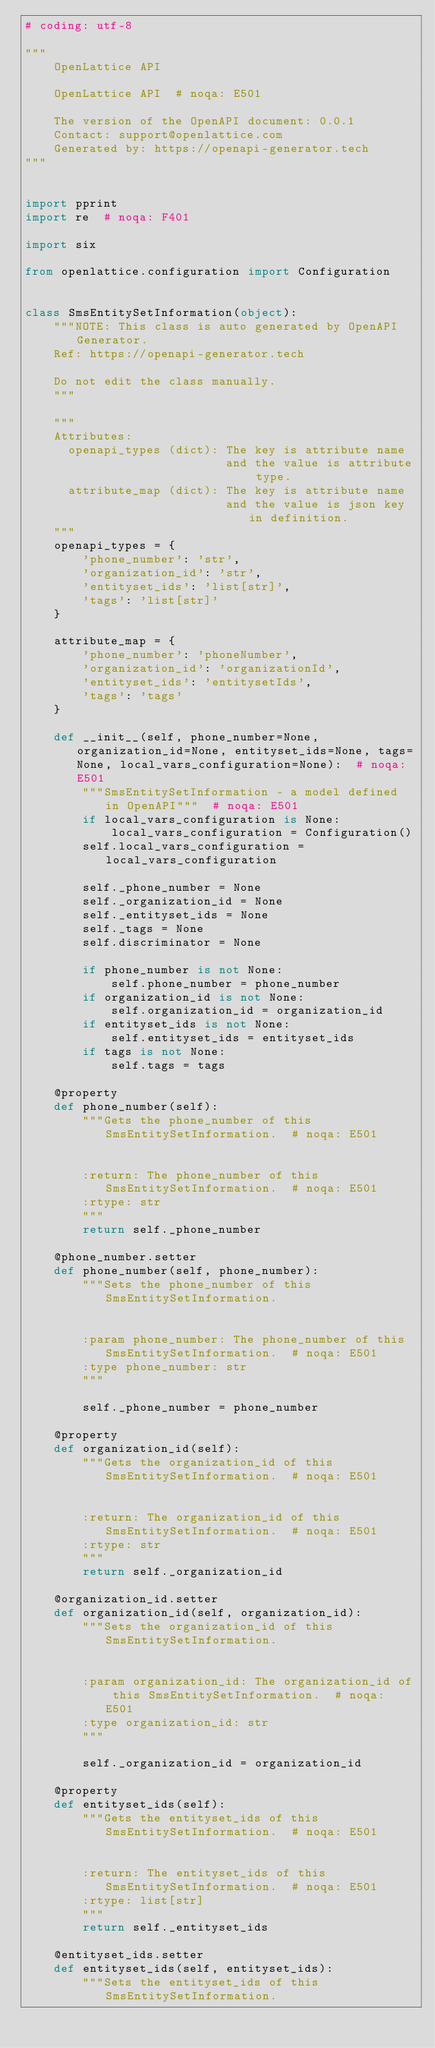Convert code to text. <code><loc_0><loc_0><loc_500><loc_500><_Python_># coding: utf-8

"""
    OpenLattice API

    OpenLattice API  # noqa: E501

    The version of the OpenAPI document: 0.0.1
    Contact: support@openlattice.com
    Generated by: https://openapi-generator.tech
"""


import pprint
import re  # noqa: F401

import six

from openlattice.configuration import Configuration


class SmsEntitySetInformation(object):
    """NOTE: This class is auto generated by OpenAPI Generator.
    Ref: https://openapi-generator.tech

    Do not edit the class manually.
    """

    """
    Attributes:
      openapi_types (dict): The key is attribute name
                            and the value is attribute type.
      attribute_map (dict): The key is attribute name
                            and the value is json key in definition.
    """
    openapi_types = {
        'phone_number': 'str',
        'organization_id': 'str',
        'entityset_ids': 'list[str]',
        'tags': 'list[str]'
    }

    attribute_map = {
        'phone_number': 'phoneNumber',
        'organization_id': 'organizationId',
        'entityset_ids': 'entitysetIds',
        'tags': 'tags'
    }

    def __init__(self, phone_number=None, organization_id=None, entityset_ids=None, tags=None, local_vars_configuration=None):  # noqa: E501
        """SmsEntitySetInformation - a model defined in OpenAPI"""  # noqa: E501
        if local_vars_configuration is None:
            local_vars_configuration = Configuration()
        self.local_vars_configuration = local_vars_configuration

        self._phone_number = None
        self._organization_id = None
        self._entityset_ids = None
        self._tags = None
        self.discriminator = None

        if phone_number is not None:
            self.phone_number = phone_number
        if organization_id is not None:
            self.organization_id = organization_id
        if entityset_ids is not None:
            self.entityset_ids = entityset_ids
        if tags is not None:
            self.tags = tags

    @property
    def phone_number(self):
        """Gets the phone_number of this SmsEntitySetInformation.  # noqa: E501


        :return: The phone_number of this SmsEntitySetInformation.  # noqa: E501
        :rtype: str
        """
        return self._phone_number

    @phone_number.setter
    def phone_number(self, phone_number):
        """Sets the phone_number of this SmsEntitySetInformation.


        :param phone_number: The phone_number of this SmsEntitySetInformation.  # noqa: E501
        :type phone_number: str
        """

        self._phone_number = phone_number

    @property
    def organization_id(self):
        """Gets the organization_id of this SmsEntitySetInformation.  # noqa: E501


        :return: The organization_id of this SmsEntitySetInformation.  # noqa: E501
        :rtype: str
        """
        return self._organization_id

    @organization_id.setter
    def organization_id(self, organization_id):
        """Sets the organization_id of this SmsEntitySetInformation.


        :param organization_id: The organization_id of this SmsEntitySetInformation.  # noqa: E501
        :type organization_id: str
        """

        self._organization_id = organization_id

    @property
    def entityset_ids(self):
        """Gets the entityset_ids of this SmsEntitySetInformation.  # noqa: E501


        :return: The entityset_ids of this SmsEntitySetInformation.  # noqa: E501
        :rtype: list[str]
        """
        return self._entityset_ids

    @entityset_ids.setter
    def entityset_ids(self, entityset_ids):
        """Sets the entityset_ids of this SmsEntitySetInformation.

</code> 